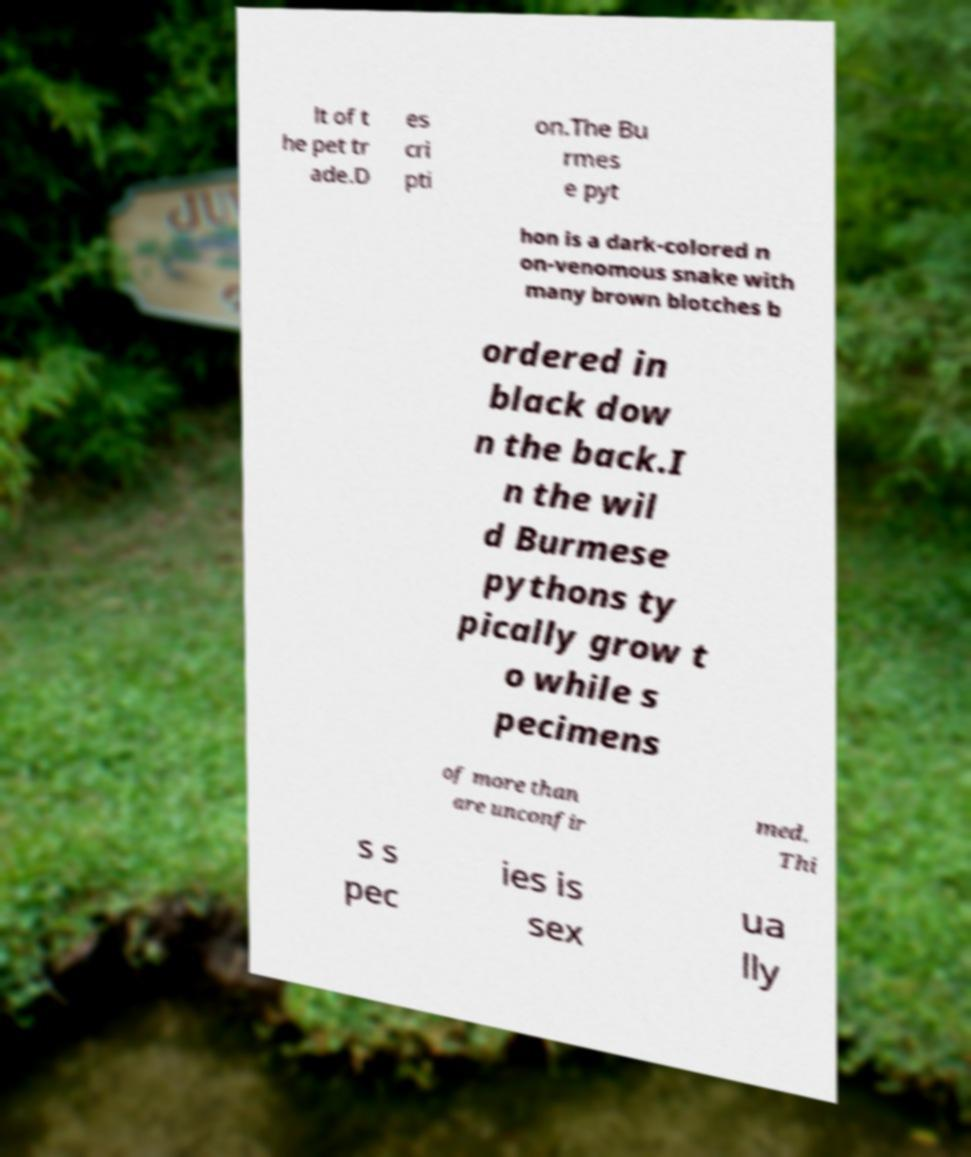I need the written content from this picture converted into text. Can you do that? lt of t he pet tr ade.D es cri pti on.The Bu rmes e pyt hon is a dark-colored n on-venomous snake with many brown blotches b ordered in black dow n the back.I n the wil d Burmese pythons ty pically grow t o while s pecimens of more than are unconfir med. Thi s s pec ies is sex ua lly 